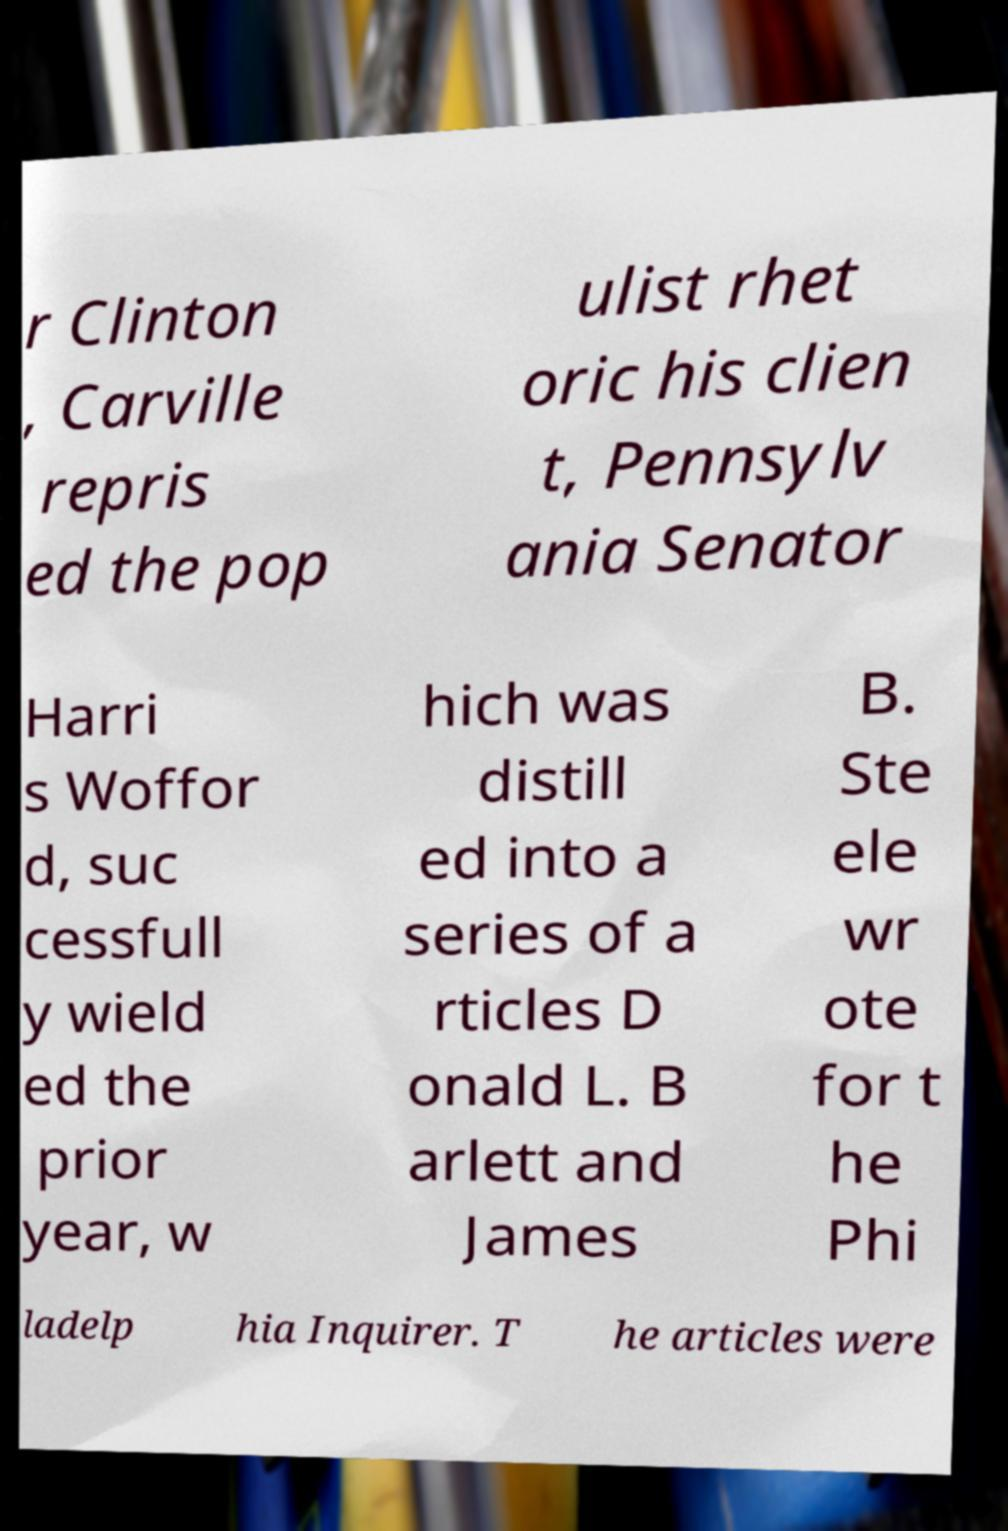There's text embedded in this image that I need extracted. Can you transcribe it verbatim? r Clinton , Carville repris ed the pop ulist rhet oric his clien t, Pennsylv ania Senator Harri s Woffor d, suc cessfull y wield ed the prior year, w hich was distill ed into a series of a rticles D onald L. B arlett and James B. Ste ele wr ote for t he Phi ladelp hia Inquirer. T he articles were 